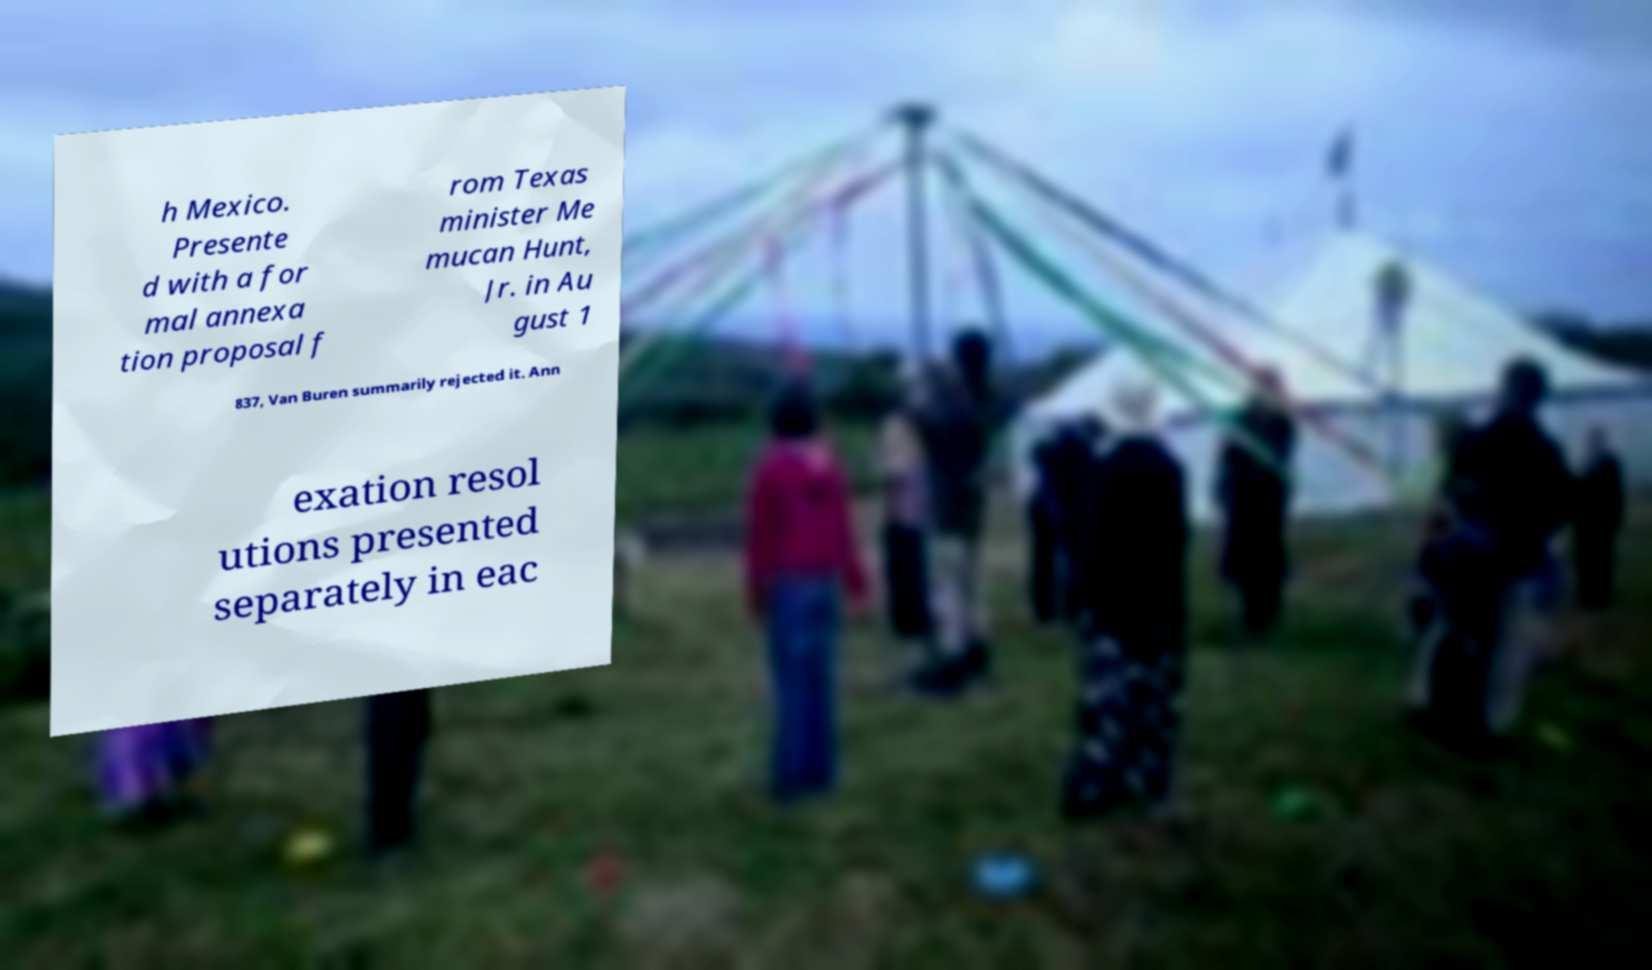Please identify and transcribe the text found in this image. h Mexico. Presente d with a for mal annexa tion proposal f rom Texas minister Me mucan Hunt, Jr. in Au gust 1 837, Van Buren summarily rejected it. Ann exation resol utions presented separately in eac 